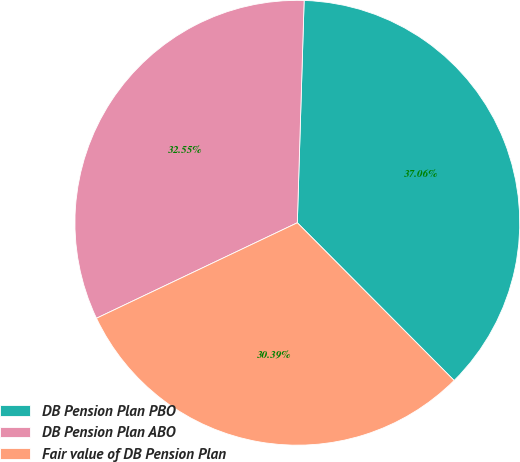Convert chart to OTSL. <chart><loc_0><loc_0><loc_500><loc_500><pie_chart><fcel>DB Pension Plan PBO<fcel>DB Pension Plan ABO<fcel>Fair value of DB Pension Plan<nl><fcel>37.06%<fcel>32.55%<fcel>30.39%<nl></chart> 